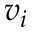<formula> <loc_0><loc_0><loc_500><loc_500>v _ { i }</formula> 